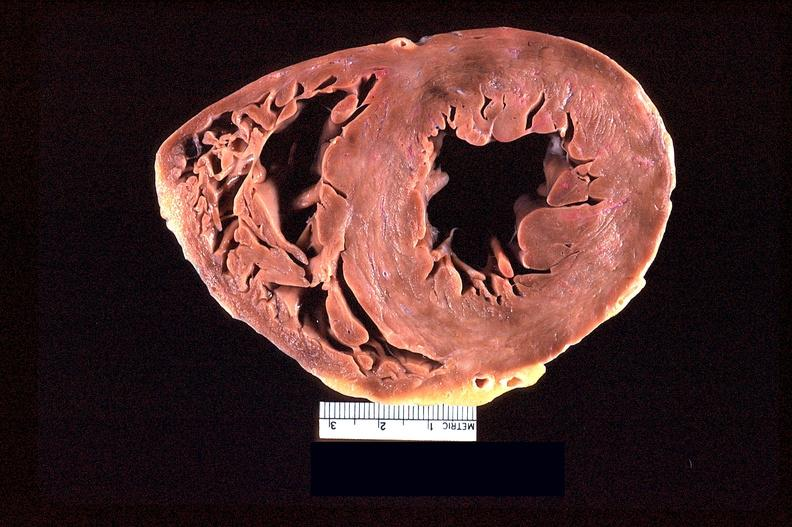s omphalocele present?
Answer the question using a single word or phrase. No 